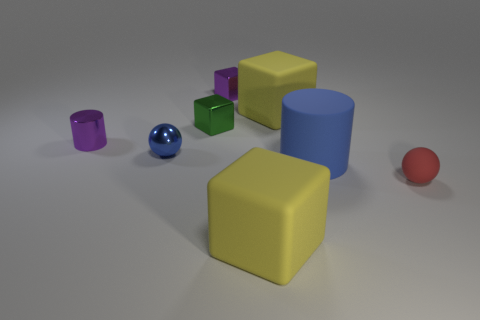Add 1 blue matte objects. How many objects exist? 9 Subtract all spheres. How many objects are left? 6 Subtract 1 red spheres. How many objects are left? 7 Subtract all tiny brown rubber cylinders. Subtract all tiny shiny blocks. How many objects are left? 6 Add 6 purple metallic things. How many purple metallic things are left? 8 Add 6 tiny purple metal blocks. How many tiny purple metal blocks exist? 7 